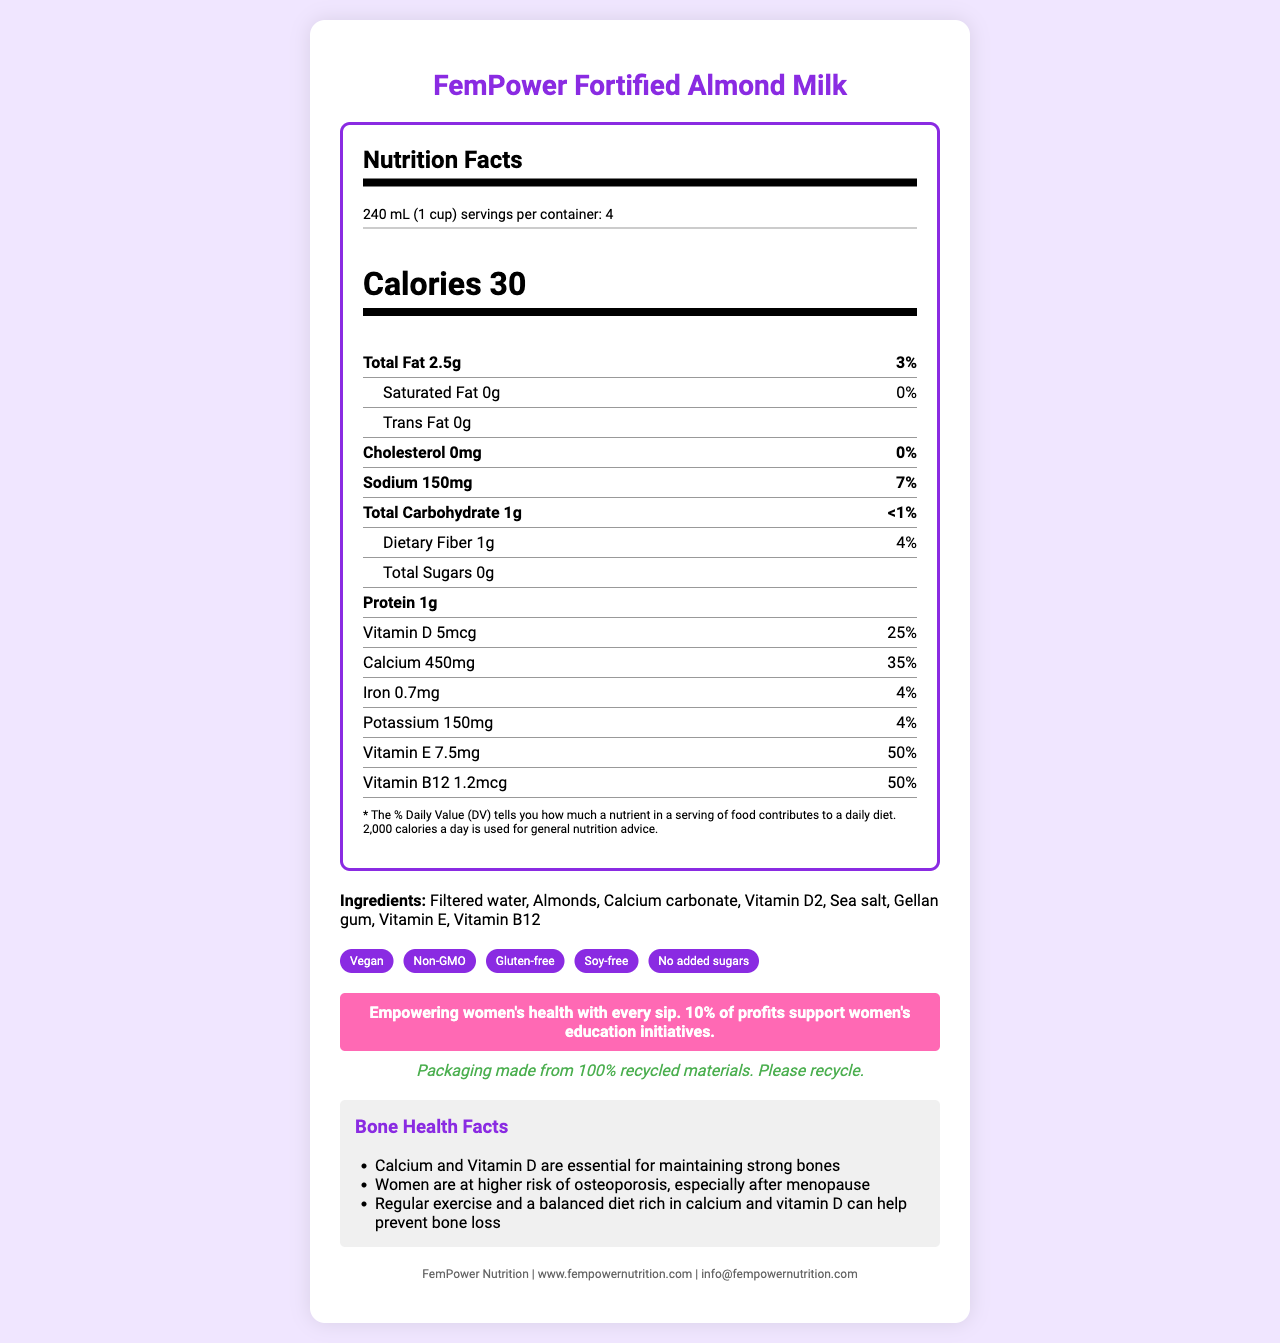what is the name of the product? The product name is titled at the top of the document.
Answer: FemPower Fortified Almond Milk how many calories are in one serving? The document lists "Calories 30" under the Nutrition Facts section.
Answer: 30 how much calcium does one serving provide? The Nutrient Facts section states "Calcium 450mg" with a daily value of 35%.
Answer: 450mg how much protein is in a serving? Under the protein section of the Nutrition Facts, it shows "Protein 1g".
Answer: 1g what is the serving size? Under the Nutrition Facts, it lists "240 mL (1 cup)".
Answer: 240 mL (1 cup) how many servings are in one container? The Nutrition Facts section lists "servings per container: 4".
Answer: 4 what is the % daily value of Vitamin D provided by one serving? A. 25% B. 35% C. 50% D. 75% The document states "Vitamin D 25%" under the Nutrition Facts section.
Answer: A which of the following is NOT an ingredient in FemPower Fortified Almond Milk? A. Filtered water B. Almonds C. Soy D. Sea salt The ingredient list does not include soy. It includes filtered water, almonds, and sea salt.
Answer: C is the product gluten-free? The claims section lists "Gluten-free".
Answer: Yes summarize the purpose and key features of this document. The document highlights the product's nutritional benefits, its role in supporting women's bone health, various claims such as vegan and non-GMO, a feminist empowerment message, and sustainability initiatives.
Answer: The document provides information about FemPower Fortified Almond Milk, a non-dairy milk alternative fortified with calcium and Vitamin D for women's bone health. It covers the Nutrition Facts, ingredients, claims, a feminist message about empowering women's health, sustainability notes, and bone health facts. how much vitamin E is in one serving? The document states "Vitamin E 7.5mg" under the Nutrition Facts section.
Answer: 7.5mg what percentage of profits supports women's education initiatives? The feminist message section states that 10% of profits support women's education initiatives.
Answer: 10% which nutrient is present in the highest daily value percentage? The nutrient with the highest daily value percentage listed is Vitamin E at 50%.
Answer: Vitamin E (50%) does the product come in recycled packaging? The sustainability note section mentions that the packaging is made from 100% recycled materials.
Answer: Yes does the document mention if the product contains added sugars? The claims section states "No added sugars".
Answer: No what is the contact email for the company? The company info section lists "info@fempowernutrition.com" as the contact email.
Answer: info@fempowernutrition.com what is the name of the company that produces FemPower Fortified Almond Milk? The company info section lists the company name as "FemPower Nutrition."
Answer: FemPower Nutrition what is the total fat content in one serving and its daily value percentage? Under total fat in the Nutrition Facts, it states "2.5g" and "3%".
Answer: 2.5g, 3% what specific risk related to women's health is mentioned in the bone health facts? The bone health facts note that women are at higher risk of osteoporosis, especially after menopause.
Answer: Osteoporosis, especially after menopause how are calcium and vitamin D described in terms of their importance for bone health? The bone health facts section mentions that calcium and vitamin D are essential for maintaining strong bones.
Answer: Essential for maintaining strong bones what type of fat is listed as 0g in the Nutrition Facts? The document lists both Saturated Fat and Trans Fat as 0g under the Nutrition Facts section.
Answer: Saturated Fat and Trans Fat how much sodium is in one serving, and what is its daily value percentage? The document states "Sodium 150mg" and "7%" under the Nutrition Facts section.
Answer: 150mg, 7% what information is provided about exercise and diet in relation to bone health? The bone health facts mention that regular exercise and a balanced diet rich in calcium and vitamin D can help prevent bone loss.
Answer: Regular exercise and a balanced diet rich in calcium and vitamin D can help prevent bone loss where can more information about the company be found online? The company info section lists the website as "www.fempowernutrition.com".
Answer: www.fempowernutrition.com what are some of the claims made about FemPower Fortified Almond Milk? The claims section lists these features of the product.
Answer: Vegan, Non-GMO, Gluten-free, Soy-free, No added sugars does the product contain iron? If so, how much? The Nutrition Facts section states "Iron 0.7mg".
Answer: Yes, 0.7mg what is the main message related to women's rights in the document? The feminist message states "Empowering women's health with every sip. 10% of profits support women's education initiatives".
Answer: Empowering women's health with every sip. 10% of profits support women's education initiatives. how much Vitamin B12 is in one serving and its daily value percentage? The document lists "Vitamin B12 1.2mcg" and "50%" under the Nutrition Facts section.
Answer: 1.2mcg, 50% 